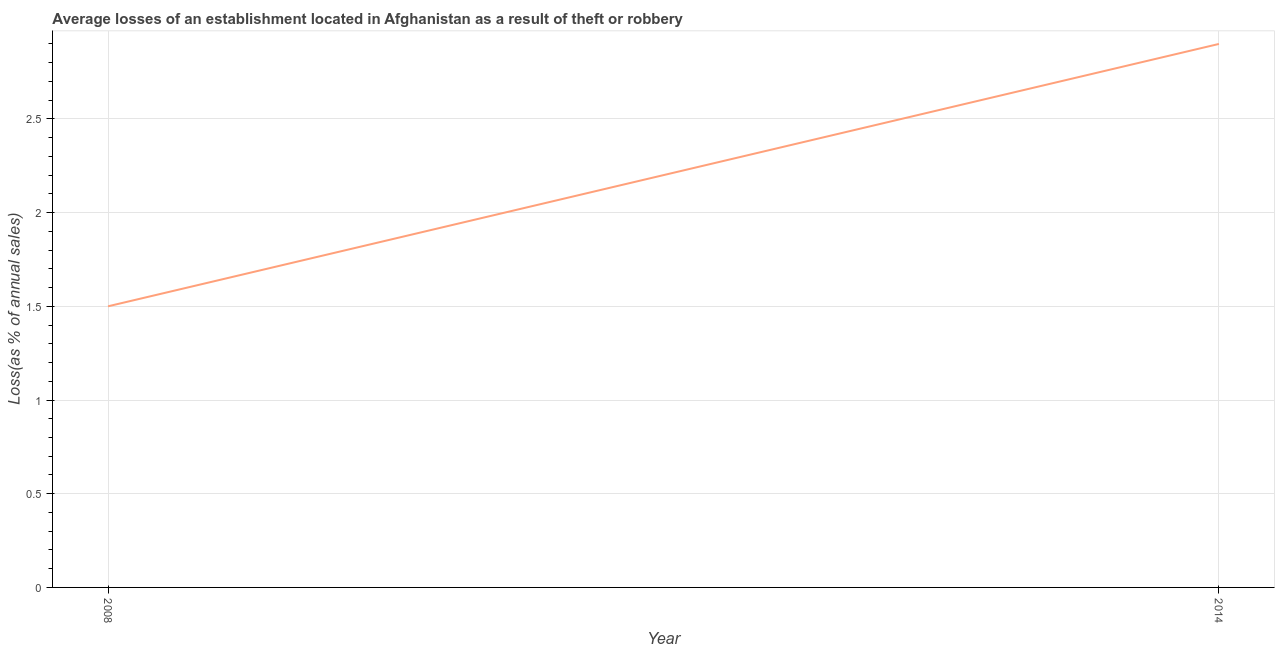What is the losses due to theft in 2008?
Your answer should be compact. 1.5. Across all years, what is the maximum losses due to theft?
Offer a very short reply. 2.9. Across all years, what is the minimum losses due to theft?
Make the answer very short. 1.5. In which year was the losses due to theft maximum?
Your answer should be compact. 2014. In which year was the losses due to theft minimum?
Give a very brief answer. 2008. What is the difference between the losses due to theft in 2008 and 2014?
Provide a succinct answer. -1.4. What is the average losses due to theft per year?
Your answer should be compact. 2.2. What is the median losses due to theft?
Your answer should be very brief. 2.2. In how many years, is the losses due to theft greater than 1.2 %?
Provide a succinct answer. 2. What is the ratio of the losses due to theft in 2008 to that in 2014?
Give a very brief answer. 0.52. Is the losses due to theft in 2008 less than that in 2014?
Give a very brief answer. Yes. Does the losses due to theft monotonically increase over the years?
Offer a terse response. Yes. How many lines are there?
Keep it short and to the point. 1. What is the difference between two consecutive major ticks on the Y-axis?
Provide a succinct answer. 0.5. Does the graph contain any zero values?
Ensure brevity in your answer.  No. What is the title of the graph?
Ensure brevity in your answer.  Average losses of an establishment located in Afghanistan as a result of theft or robbery. What is the label or title of the X-axis?
Your answer should be compact. Year. What is the label or title of the Y-axis?
Ensure brevity in your answer.  Loss(as % of annual sales). What is the difference between the Loss(as % of annual sales) in 2008 and 2014?
Keep it short and to the point. -1.4. What is the ratio of the Loss(as % of annual sales) in 2008 to that in 2014?
Your answer should be compact. 0.52. 